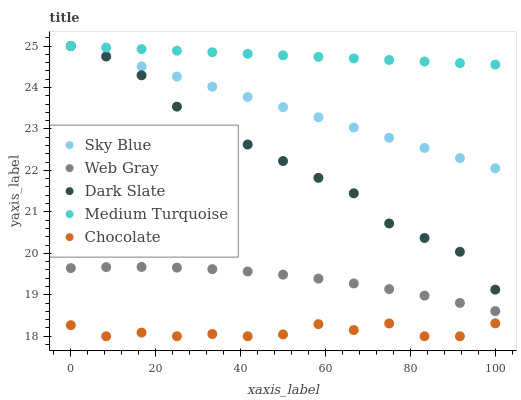Does Chocolate have the minimum area under the curve?
Answer yes or no. Yes. Does Medium Turquoise have the maximum area under the curve?
Answer yes or no. Yes. Does Sky Blue have the minimum area under the curve?
Answer yes or no. No. Does Sky Blue have the maximum area under the curve?
Answer yes or no. No. Is Sky Blue the smoothest?
Answer yes or no. Yes. Is Chocolate the roughest?
Answer yes or no. Yes. Is Web Gray the smoothest?
Answer yes or no. No. Is Web Gray the roughest?
Answer yes or no. No. Does Chocolate have the lowest value?
Answer yes or no. Yes. Does Sky Blue have the lowest value?
Answer yes or no. No. Does Dark Slate have the highest value?
Answer yes or no. Yes. Does Web Gray have the highest value?
Answer yes or no. No. Is Chocolate less than Dark Slate?
Answer yes or no. Yes. Is Medium Turquoise greater than Chocolate?
Answer yes or no. Yes. Does Dark Slate intersect Sky Blue?
Answer yes or no. Yes. Is Dark Slate less than Sky Blue?
Answer yes or no. No. Is Dark Slate greater than Sky Blue?
Answer yes or no. No. Does Chocolate intersect Dark Slate?
Answer yes or no. No. 